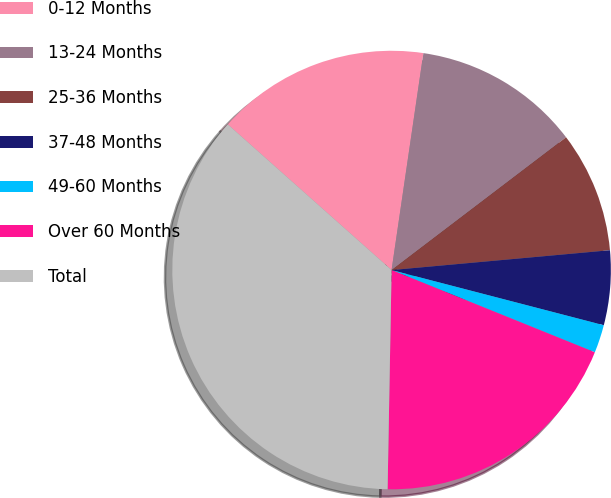Convert chart to OTSL. <chart><loc_0><loc_0><loc_500><loc_500><pie_chart><fcel>0-12 Months<fcel>13-24 Months<fcel>25-36 Months<fcel>37-48 Months<fcel>49-60 Months<fcel>Over 60 Months<fcel>Total<nl><fcel>15.75%<fcel>12.33%<fcel>8.91%<fcel>5.49%<fcel>2.07%<fcel>19.17%<fcel>36.28%<nl></chart> 